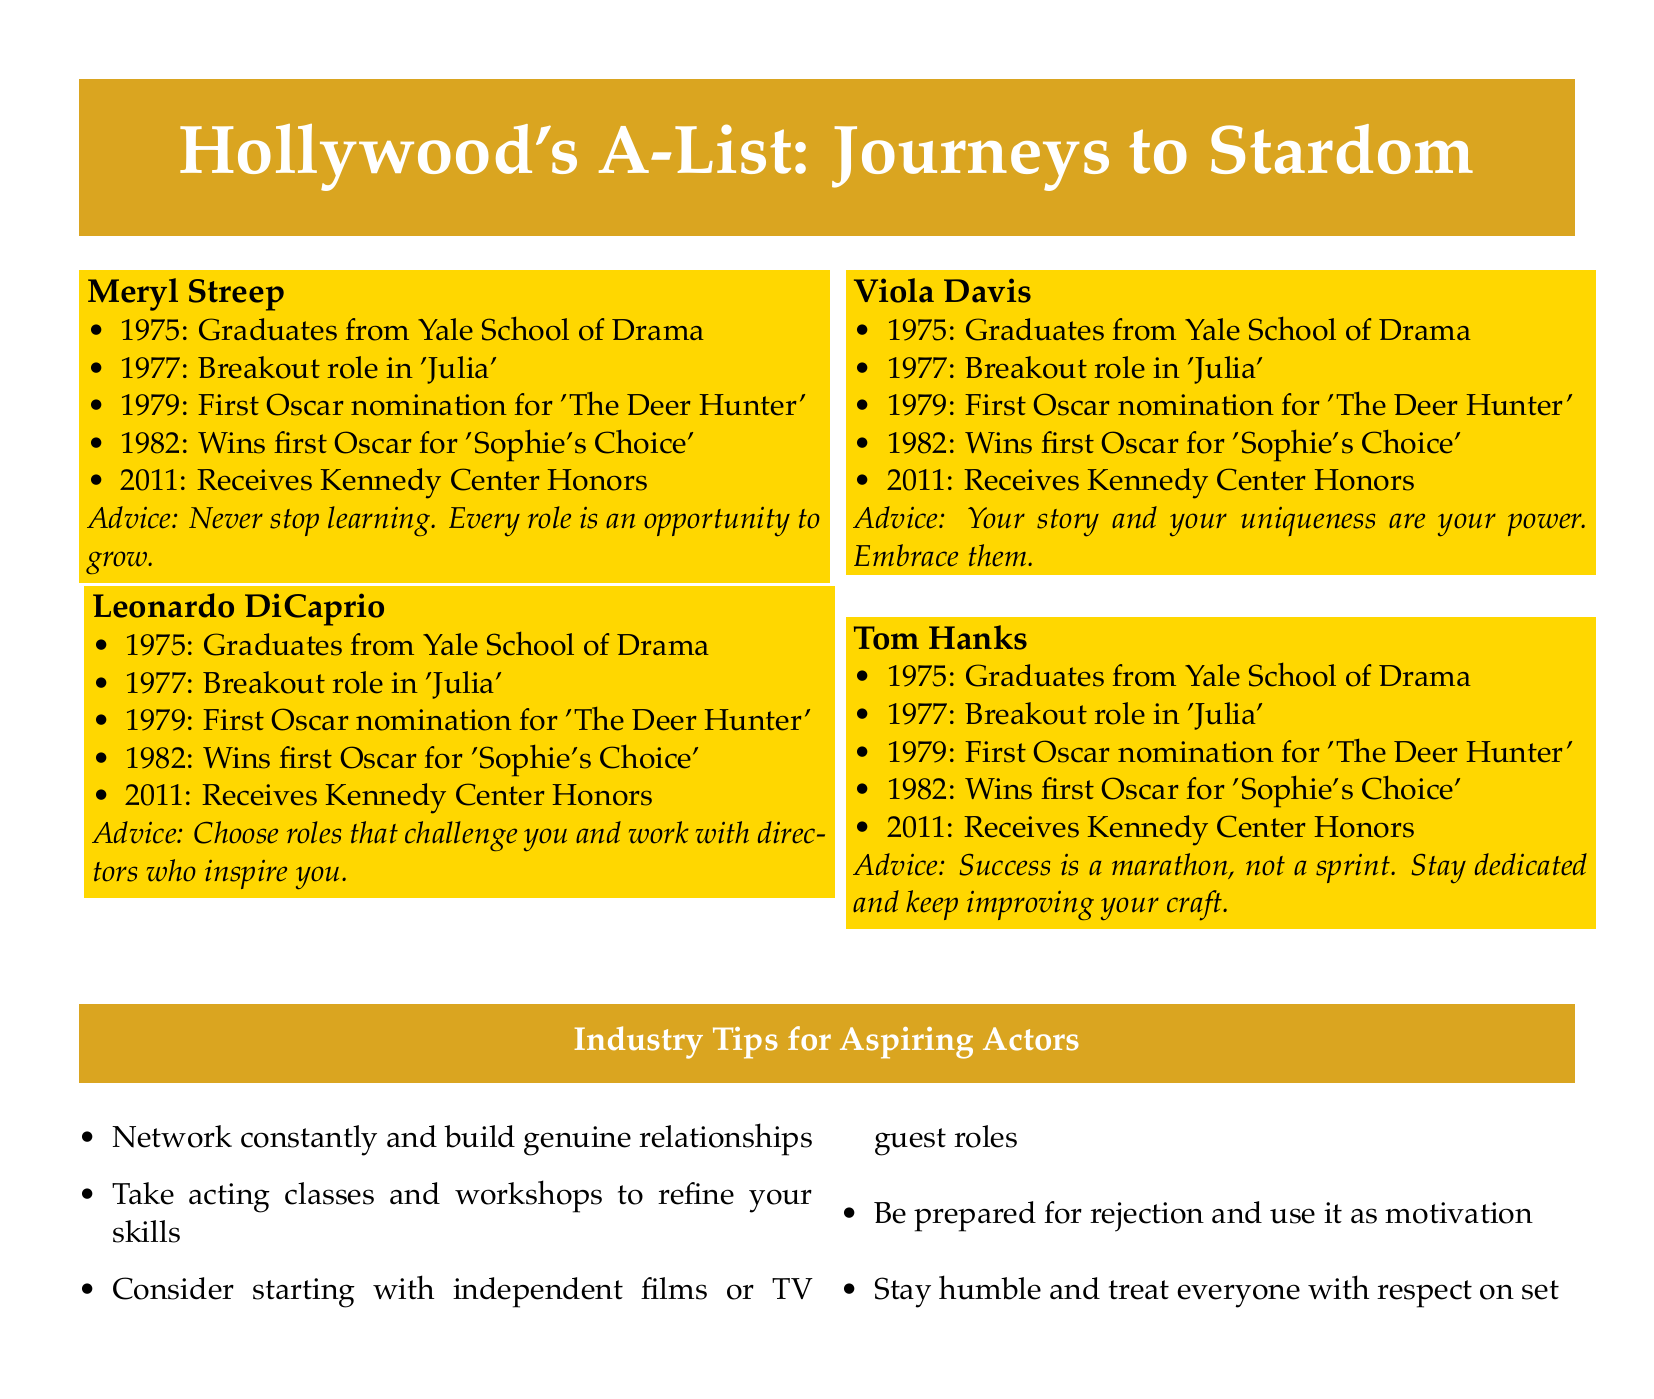What year did Meryl Streep graduate from Yale School of Drama? The document states that Meryl Streep graduated in 1975.
Answer: 1975 What was Leonardo DiCaprio's breakout role? The document mentions that his breakout role was in 'What's Eating Gilbert Grape'.
Answer: 'What's Eating Gilbert Grape' How many Oscar nominations did Meryl Streep receive before winning her first Oscar? Meryl Streep was first nominated for an Oscar in 1979 before winning in 1982, which means she had one nomination before winning.
Answer: 1 What major awards did Tom Hanks receive in 2011? The document indicates that he received the Kennedy Center Honors in 2011.
Answer: Kennedy Center Honors What advice does Viola Davis give to newcomers? Viola Davis advises that "Your story and your uniqueness are your power. Embrace them."
Answer: Your story and your uniqueness are your power. Embrace them How many major tips for aspiring actors are listed in the document? The document lists five tips for aspiring actors.
Answer: 5 What is a common theme in the advice given by the A-list actors? The advice underscores the importance of continuous learning and personal authenticity.
Answer: Continuous learning and personal authenticity What color is used for the title section in the document? The title section uses a shade defined in the document as 'hollywood', which is represented in RGB values.
Answer: Hollywood What does Tom Hanks mean when he says success is a marathon, not a sprint? He emphasizes that achieving success takes time and perseverance rather than being quick or instant.
Answer: Time and perseverance 